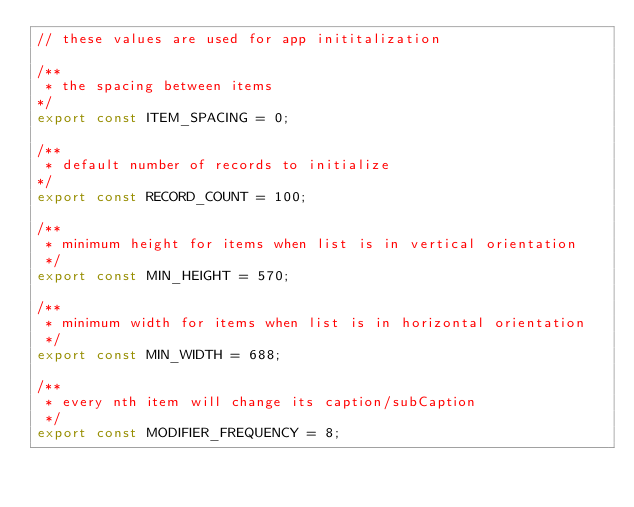<code> <loc_0><loc_0><loc_500><loc_500><_JavaScript_>// these values are used for app inititalization

/**
 * the spacing between items
*/
export const ITEM_SPACING = 0;

/**
 * default number of records to initialize
*/
export const RECORD_COUNT = 100;

/**
 * minimum height for items when list is in vertical orientation
 */
export const MIN_HEIGHT = 570;

/**
 * minimum width for items when list is in horizontal orientation
 */
export const MIN_WIDTH = 688;

/**
 * every nth item will change its caption/subCaption
 */
export const MODIFIER_FREQUENCY = 8;
</code> 